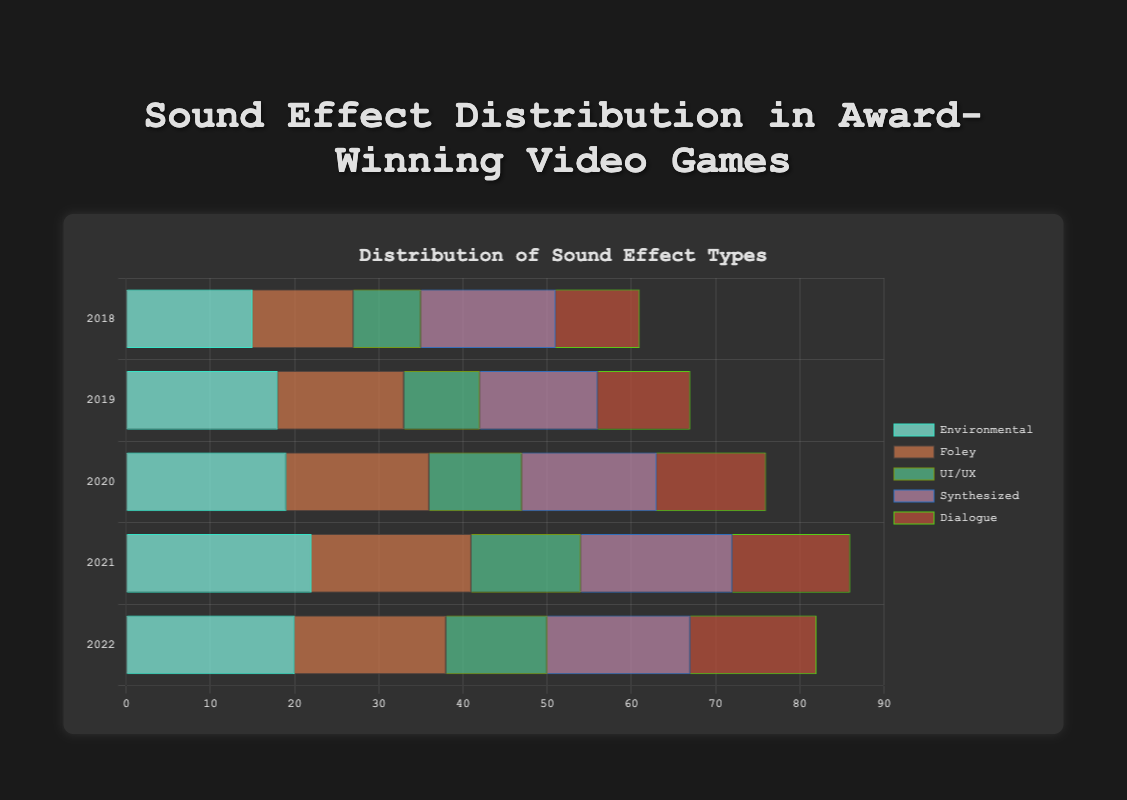What was the most common sound effect type in award-winning games in 2021? To find the most common sound effect type for 2021, compare the lengths of the respective bars. Environmental is at 22, Foley is at 19, UI/UX is at 13, Synthesized is at 18, and Dialogue is at 14. The highest is the Environmental effect with 22.
Answer: Environmental Which sound effect type increased the most from 2018 to 2021? To determine the increase, subtract the 2018 values from the 2021 values for each effect type: Environmental (22 - 15 = 7), Foley (19 - 12 = 7), UI/UX (13 - 8 = 5), Synthesized (18 - 16 = 2), Dialogue (14 - 10 = 4). Both Environmental and Foley have the highest increase of 7.
Answer: Environmental and Foley What's the average number of Environmental sound effects across all years? Add the Environmental counts for each year: 15 + 18 + 19 + 22 + 20 = 94, and divide by the number of years (5): 94 / 5 = 18.8
Answer: 18.8 Which year had the lowest number of UI/UX sound effects? Compare the values for UI/UX across years: 2018 (8), 2019 (9), 2020 (11), 2021 (13), 2022 (12). The lowest value is in 2018 with 8.
Answer: 2018 How did the number of Synthesized sound effects change from 2019 to 2022? Look at the Synthesized values for 2019 and 2022: 2019 (14), 2022 (17). Calculate the change (17 - 14 = 3).
Answer: Increased by 3 Which sound effect type had the smallest variation over the years? Calculate the range for each type: Environmental (22 - 15 = 7), Foley (19 - 12 = 7), UI/UX (13 - 8 = 5), Synthesized (18 - 14 = 4), Dialogue (15 - 10 = 5). The smallest range is for Synthesized with a range of 4.
Answer: Synthesized What combination of two sound types had the highest total in 2020? Add pairs of 2020 values: Environmental (19) + Foley (17) = 36, Environmental (19) + UI/UX (11) = 30, Environmental (19) + Synthesized (16) = 35, Environmental (19) + Dialogue (13) = 32, Foley (17) + UI/UX (11) = 28, Foley (17) + Synthesized (16) = 33, Foley (17) + Dialogue (13) = 30, UI/UX (11) + Synthesized (16) = 27, UI/UX (11) + Dialogue (13) = 24, Synthesized (16) + Dialogue (13) = 29. The highest combination is Environmental and Foley with a total of 36.
Answer: Environmental and Foley 